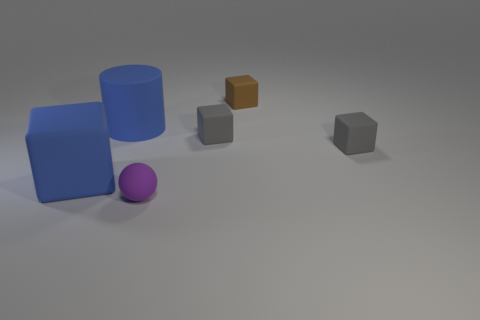Add 2 brown rubber objects. How many objects exist? 8 Subtract all spheres. How many objects are left? 5 Subtract 0 purple cylinders. How many objects are left? 6 Subtract all big blue cylinders. Subtract all brown objects. How many objects are left? 4 Add 4 large blue things. How many large blue things are left? 6 Add 2 tiny spheres. How many tiny spheres exist? 3 